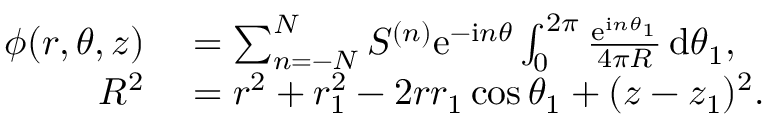<formula> <loc_0><loc_0><loc_500><loc_500>\begin{array} { r l } { \phi ( r , \theta , z ) } & = \sum _ { n = - N } ^ { N } S ^ { ( n ) } e ^ { - i n \theta } \int _ { 0 } ^ { 2 \pi } \frac { e ^ { i n \theta _ { 1 } } } { 4 \pi R } \, d \theta _ { 1 } , } \\ { R ^ { 2 } } & = r ^ { 2 } + r _ { 1 } ^ { 2 } - 2 r r _ { 1 } \cos \theta _ { 1 } + ( z - z _ { 1 } ) ^ { 2 } . } \end{array}</formula> 